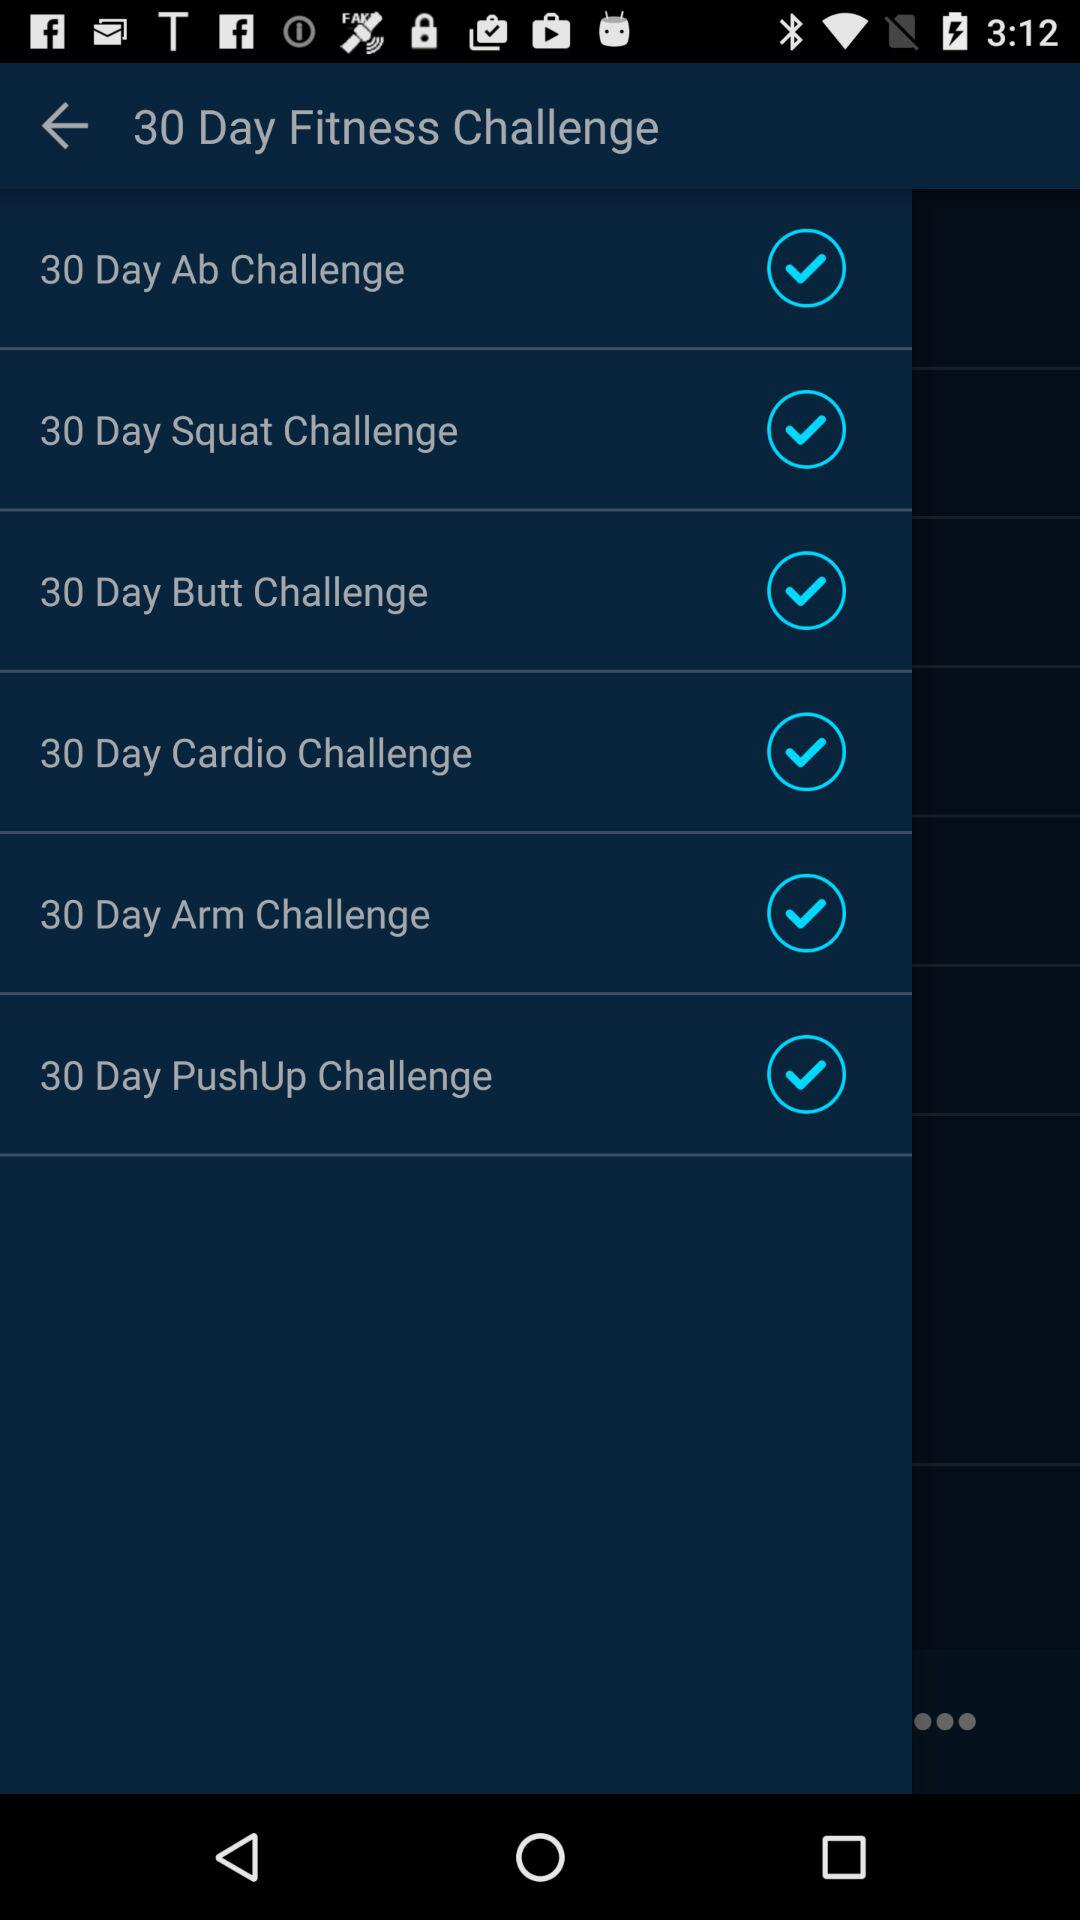When did the fitness challenge begin?
When the provided information is insufficient, respond with <no answer>. <no answer> 